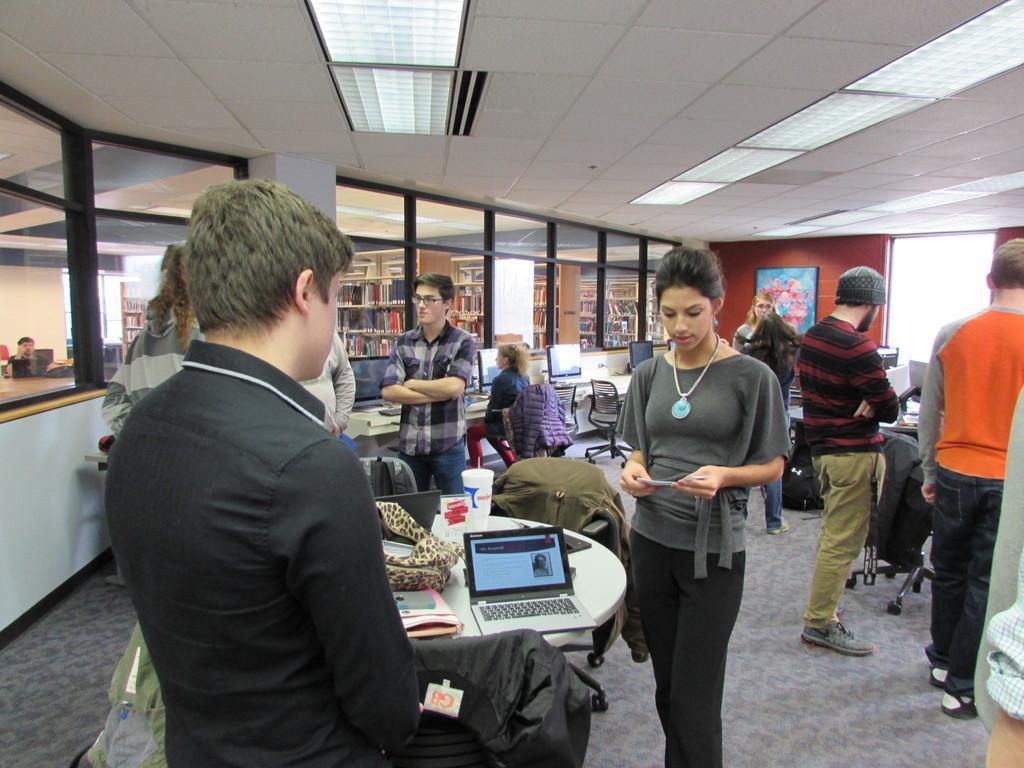Can you describe this image briefly? This picture is of inside the room. On the right there are two persons standing. In the center there is a woman wearing grey color t-shirt, holding a paper and standing. There is a man wearing a black color shirt and standing. There is a table on the top of which laptops, glass, book and a backpack is placed, behind that there is a man wearing shirt and standing. In the background there is a woman sitting on the chair and we can see the shelves containing books and a picture frame hanging on the wall and on left corner a person sitting on the chair. 